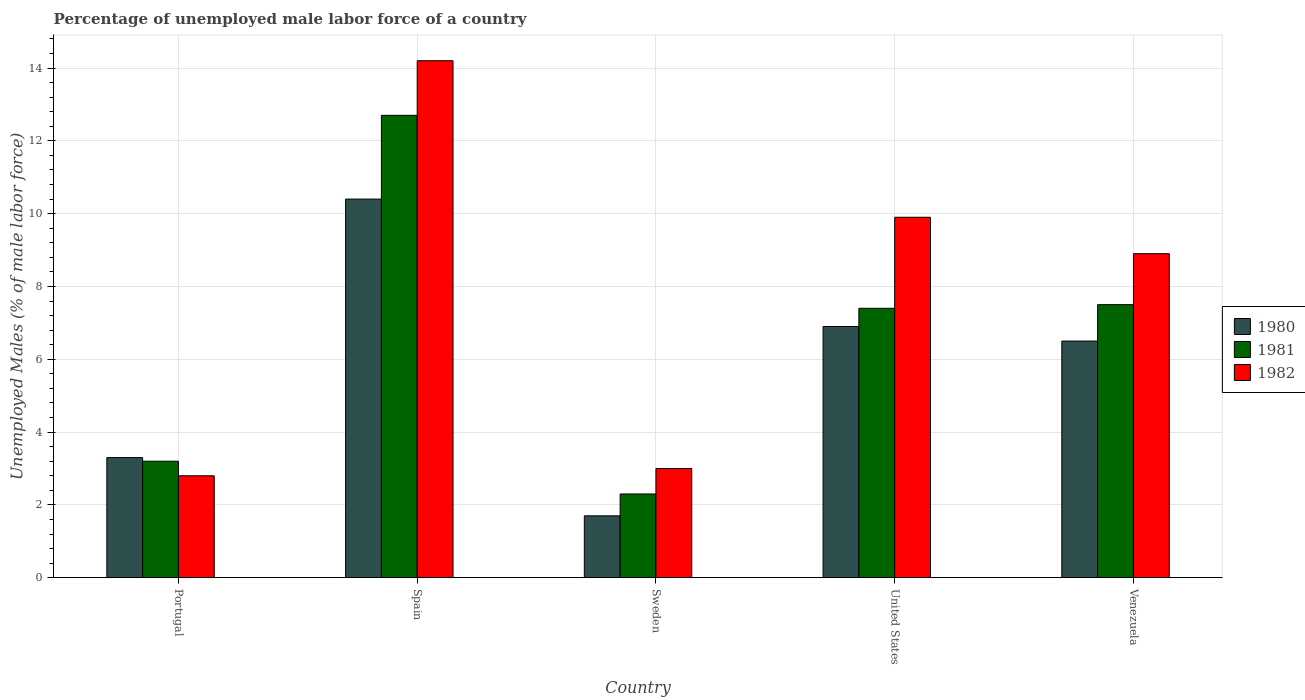Are the number of bars per tick equal to the number of legend labels?
Your answer should be very brief. Yes. What is the percentage of unemployed male labor force in 1980 in Sweden?
Your response must be concise. 1.7. Across all countries, what is the maximum percentage of unemployed male labor force in 1981?
Make the answer very short. 12.7. Across all countries, what is the minimum percentage of unemployed male labor force in 1981?
Offer a very short reply. 2.3. In which country was the percentage of unemployed male labor force in 1980 maximum?
Make the answer very short. Spain. What is the total percentage of unemployed male labor force in 1982 in the graph?
Offer a terse response. 38.8. What is the difference between the percentage of unemployed male labor force in 1980 in Portugal and that in Venezuela?
Offer a terse response. -3.2. What is the difference between the percentage of unemployed male labor force in 1981 in United States and the percentage of unemployed male labor force in 1982 in Spain?
Offer a terse response. -6.8. What is the average percentage of unemployed male labor force in 1982 per country?
Make the answer very short. 7.76. What is the difference between the percentage of unemployed male labor force of/in 1981 and percentage of unemployed male labor force of/in 1980 in United States?
Provide a succinct answer. 0.5. In how many countries, is the percentage of unemployed male labor force in 1980 greater than 3.2 %?
Provide a succinct answer. 4. What is the ratio of the percentage of unemployed male labor force in 1981 in Sweden to that in Venezuela?
Your answer should be very brief. 0.31. Is the percentage of unemployed male labor force in 1981 in Portugal less than that in Sweden?
Provide a succinct answer. No. What is the difference between the highest and the second highest percentage of unemployed male labor force in 1980?
Give a very brief answer. 3.5. What is the difference between the highest and the lowest percentage of unemployed male labor force in 1981?
Offer a very short reply. 10.4. Is the sum of the percentage of unemployed male labor force in 1981 in United States and Venezuela greater than the maximum percentage of unemployed male labor force in 1980 across all countries?
Provide a short and direct response. Yes. What does the 3rd bar from the left in Venezuela represents?
Offer a terse response. 1982. Is it the case that in every country, the sum of the percentage of unemployed male labor force in 1982 and percentage of unemployed male labor force in 1981 is greater than the percentage of unemployed male labor force in 1980?
Your response must be concise. Yes. Are all the bars in the graph horizontal?
Give a very brief answer. No. What is the difference between two consecutive major ticks on the Y-axis?
Ensure brevity in your answer.  2. Are the values on the major ticks of Y-axis written in scientific E-notation?
Ensure brevity in your answer.  No. What is the title of the graph?
Offer a very short reply. Percentage of unemployed male labor force of a country. Does "1991" appear as one of the legend labels in the graph?
Make the answer very short. No. What is the label or title of the Y-axis?
Offer a terse response. Unemployed Males (% of male labor force). What is the Unemployed Males (% of male labor force) in 1980 in Portugal?
Your response must be concise. 3.3. What is the Unemployed Males (% of male labor force) in 1981 in Portugal?
Your answer should be compact. 3.2. What is the Unemployed Males (% of male labor force) in 1982 in Portugal?
Give a very brief answer. 2.8. What is the Unemployed Males (% of male labor force) in 1980 in Spain?
Your answer should be very brief. 10.4. What is the Unemployed Males (% of male labor force) of 1981 in Spain?
Your response must be concise. 12.7. What is the Unemployed Males (% of male labor force) of 1982 in Spain?
Your answer should be very brief. 14.2. What is the Unemployed Males (% of male labor force) of 1980 in Sweden?
Provide a short and direct response. 1.7. What is the Unemployed Males (% of male labor force) in 1981 in Sweden?
Keep it short and to the point. 2.3. What is the Unemployed Males (% of male labor force) in 1980 in United States?
Provide a short and direct response. 6.9. What is the Unemployed Males (% of male labor force) in 1981 in United States?
Offer a terse response. 7.4. What is the Unemployed Males (% of male labor force) in 1982 in United States?
Make the answer very short. 9.9. What is the Unemployed Males (% of male labor force) in 1981 in Venezuela?
Your answer should be very brief. 7.5. What is the Unemployed Males (% of male labor force) in 1982 in Venezuela?
Make the answer very short. 8.9. Across all countries, what is the maximum Unemployed Males (% of male labor force) in 1980?
Your answer should be very brief. 10.4. Across all countries, what is the maximum Unemployed Males (% of male labor force) of 1981?
Give a very brief answer. 12.7. Across all countries, what is the maximum Unemployed Males (% of male labor force) of 1982?
Your answer should be compact. 14.2. Across all countries, what is the minimum Unemployed Males (% of male labor force) of 1980?
Give a very brief answer. 1.7. Across all countries, what is the minimum Unemployed Males (% of male labor force) of 1981?
Provide a short and direct response. 2.3. Across all countries, what is the minimum Unemployed Males (% of male labor force) of 1982?
Your response must be concise. 2.8. What is the total Unemployed Males (% of male labor force) of 1980 in the graph?
Offer a terse response. 28.8. What is the total Unemployed Males (% of male labor force) of 1981 in the graph?
Your response must be concise. 33.1. What is the total Unemployed Males (% of male labor force) of 1982 in the graph?
Provide a succinct answer. 38.8. What is the difference between the Unemployed Males (% of male labor force) in 1980 in Portugal and that in Spain?
Your answer should be very brief. -7.1. What is the difference between the Unemployed Males (% of male labor force) of 1981 in Portugal and that in Spain?
Provide a short and direct response. -9.5. What is the difference between the Unemployed Males (% of male labor force) of 1981 in Portugal and that in Sweden?
Offer a terse response. 0.9. What is the difference between the Unemployed Males (% of male labor force) of 1982 in Portugal and that in Sweden?
Provide a succinct answer. -0.2. What is the difference between the Unemployed Males (% of male labor force) of 1980 in Portugal and that in Venezuela?
Your answer should be very brief. -3.2. What is the difference between the Unemployed Males (% of male labor force) in 1982 in Portugal and that in Venezuela?
Provide a short and direct response. -6.1. What is the difference between the Unemployed Males (% of male labor force) in 1981 in Spain and that in Sweden?
Offer a terse response. 10.4. What is the difference between the Unemployed Males (% of male labor force) in 1982 in Spain and that in Sweden?
Ensure brevity in your answer.  11.2. What is the difference between the Unemployed Males (% of male labor force) of 1980 in Spain and that in United States?
Your response must be concise. 3.5. What is the difference between the Unemployed Males (% of male labor force) in 1981 in Spain and that in Venezuela?
Your response must be concise. 5.2. What is the difference between the Unemployed Males (% of male labor force) in 1981 in Sweden and that in Venezuela?
Give a very brief answer. -5.2. What is the difference between the Unemployed Males (% of male labor force) of 1982 in Sweden and that in Venezuela?
Ensure brevity in your answer.  -5.9. What is the difference between the Unemployed Males (% of male labor force) of 1980 in United States and that in Venezuela?
Your response must be concise. 0.4. What is the difference between the Unemployed Males (% of male labor force) of 1980 in Portugal and the Unemployed Males (% of male labor force) of 1981 in Spain?
Offer a very short reply. -9.4. What is the difference between the Unemployed Males (% of male labor force) of 1981 in Portugal and the Unemployed Males (% of male labor force) of 1982 in Spain?
Offer a terse response. -11. What is the difference between the Unemployed Males (% of male labor force) of 1980 in Portugal and the Unemployed Males (% of male labor force) of 1982 in Sweden?
Offer a terse response. 0.3. What is the difference between the Unemployed Males (% of male labor force) in 1980 in Portugal and the Unemployed Males (% of male labor force) in 1981 in United States?
Keep it short and to the point. -4.1. What is the difference between the Unemployed Males (% of male labor force) in 1980 in Portugal and the Unemployed Males (% of male labor force) in 1982 in United States?
Ensure brevity in your answer.  -6.6. What is the difference between the Unemployed Males (% of male labor force) of 1981 in Portugal and the Unemployed Males (% of male labor force) of 1982 in United States?
Ensure brevity in your answer.  -6.7. What is the difference between the Unemployed Males (% of male labor force) of 1980 in Portugal and the Unemployed Males (% of male labor force) of 1981 in Venezuela?
Your response must be concise. -4.2. What is the difference between the Unemployed Males (% of male labor force) in 1981 in Portugal and the Unemployed Males (% of male labor force) in 1982 in Venezuela?
Your response must be concise. -5.7. What is the difference between the Unemployed Males (% of male labor force) of 1980 in Spain and the Unemployed Males (% of male labor force) of 1981 in Sweden?
Provide a succinct answer. 8.1. What is the difference between the Unemployed Males (% of male labor force) in 1980 in Spain and the Unemployed Males (% of male labor force) in 1982 in United States?
Provide a short and direct response. 0.5. What is the difference between the Unemployed Males (% of male labor force) in 1980 in Spain and the Unemployed Males (% of male labor force) in 1982 in Venezuela?
Provide a short and direct response. 1.5. What is the difference between the Unemployed Males (% of male labor force) of 1980 in Sweden and the Unemployed Males (% of male labor force) of 1981 in Venezuela?
Provide a succinct answer. -5.8. What is the difference between the Unemployed Males (% of male labor force) in 1981 in Sweden and the Unemployed Males (% of male labor force) in 1982 in Venezuela?
Make the answer very short. -6.6. What is the difference between the Unemployed Males (% of male labor force) of 1980 in United States and the Unemployed Males (% of male labor force) of 1982 in Venezuela?
Make the answer very short. -2. What is the average Unemployed Males (% of male labor force) in 1980 per country?
Make the answer very short. 5.76. What is the average Unemployed Males (% of male labor force) of 1981 per country?
Ensure brevity in your answer.  6.62. What is the average Unemployed Males (% of male labor force) in 1982 per country?
Provide a short and direct response. 7.76. What is the difference between the Unemployed Males (% of male labor force) in 1980 and Unemployed Males (% of male labor force) in 1982 in Spain?
Keep it short and to the point. -3.8. What is the difference between the Unemployed Males (% of male labor force) of 1981 and Unemployed Males (% of male labor force) of 1982 in Spain?
Your answer should be compact. -1.5. What is the difference between the Unemployed Males (% of male labor force) of 1980 and Unemployed Males (% of male labor force) of 1982 in Sweden?
Provide a short and direct response. -1.3. What is the difference between the Unemployed Males (% of male labor force) of 1981 and Unemployed Males (% of male labor force) of 1982 in Sweden?
Provide a short and direct response. -0.7. What is the difference between the Unemployed Males (% of male labor force) in 1980 and Unemployed Males (% of male labor force) in 1981 in United States?
Provide a short and direct response. -0.5. What is the difference between the Unemployed Males (% of male labor force) in 1980 and Unemployed Males (% of male labor force) in 1982 in United States?
Give a very brief answer. -3. What is the difference between the Unemployed Males (% of male labor force) in 1981 and Unemployed Males (% of male labor force) in 1982 in United States?
Offer a terse response. -2.5. What is the difference between the Unemployed Males (% of male labor force) in 1980 and Unemployed Males (% of male labor force) in 1981 in Venezuela?
Ensure brevity in your answer.  -1. What is the difference between the Unemployed Males (% of male labor force) of 1980 and Unemployed Males (% of male labor force) of 1982 in Venezuela?
Offer a terse response. -2.4. What is the ratio of the Unemployed Males (% of male labor force) of 1980 in Portugal to that in Spain?
Your answer should be compact. 0.32. What is the ratio of the Unemployed Males (% of male labor force) of 1981 in Portugal to that in Spain?
Provide a succinct answer. 0.25. What is the ratio of the Unemployed Males (% of male labor force) of 1982 in Portugal to that in Spain?
Make the answer very short. 0.2. What is the ratio of the Unemployed Males (% of male labor force) in 1980 in Portugal to that in Sweden?
Give a very brief answer. 1.94. What is the ratio of the Unemployed Males (% of male labor force) in 1981 in Portugal to that in Sweden?
Your answer should be very brief. 1.39. What is the ratio of the Unemployed Males (% of male labor force) of 1980 in Portugal to that in United States?
Keep it short and to the point. 0.48. What is the ratio of the Unemployed Males (% of male labor force) of 1981 in Portugal to that in United States?
Provide a short and direct response. 0.43. What is the ratio of the Unemployed Males (% of male labor force) in 1982 in Portugal to that in United States?
Keep it short and to the point. 0.28. What is the ratio of the Unemployed Males (% of male labor force) in 1980 in Portugal to that in Venezuela?
Provide a succinct answer. 0.51. What is the ratio of the Unemployed Males (% of male labor force) in 1981 in Portugal to that in Venezuela?
Ensure brevity in your answer.  0.43. What is the ratio of the Unemployed Males (% of male labor force) in 1982 in Portugal to that in Venezuela?
Your answer should be very brief. 0.31. What is the ratio of the Unemployed Males (% of male labor force) of 1980 in Spain to that in Sweden?
Your answer should be very brief. 6.12. What is the ratio of the Unemployed Males (% of male labor force) in 1981 in Spain to that in Sweden?
Make the answer very short. 5.52. What is the ratio of the Unemployed Males (% of male labor force) of 1982 in Spain to that in Sweden?
Your answer should be compact. 4.73. What is the ratio of the Unemployed Males (% of male labor force) of 1980 in Spain to that in United States?
Keep it short and to the point. 1.51. What is the ratio of the Unemployed Males (% of male labor force) of 1981 in Spain to that in United States?
Your response must be concise. 1.72. What is the ratio of the Unemployed Males (% of male labor force) of 1982 in Spain to that in United States?
Your answer should be very brief. 1.43. What is the ratio of the Unemployed Males (% of male labor force) of 1980 in Spain to that in Venezuela?
Provide a short and direct response. 1.6. What is the ratio of the Unemployed Males (% of male labor force) in 1981 in Spain to that in Venezuela?
Keep it short and to the point. 1.69. What is the ratio of the Unemployed Males (% of male labor force) in 1982 in Spain to that in Venezuela?
Keep it short and to the point. 1.6. What is the ratio of the Unemployed Males (% of male labor force) in 1980 in Sweden to that in United States?
Give a very brief answer. 0.25. What is the ratio of the Unemployed Males (% of male labor force) in 1981 in Sweden to that in United States?
Provide a succinct answer. 0.31. What is the ratio of the Unemployed Males (% of male labor force) of 1982 in Sweden to that in United States?
Your answer should be very brief. 0.3. What is the ratio of the Unemployed Males (% of male labor force) in 1980 in Sweden to that in Venezuela?
Give a very brief answer. 0.26. What is the ratio of the Unemployed Males (% of male labor force) of 1981 in Sweden to that in Venezuela?
Provide a short and direct response. 0.31. What is the ratio of the Unemployed Males (% of male labor force) of 1982 in Sweden to that in Venezuela?
Your answer should be compact. 0.34. What is the ratio of the Unemployed Males (% of male labor force) in 1980 in United States to that in Venezuela?
Provide a short and direct response. 1.06. What is the ratio of the Unemployed Males (% of male labor force) in 1981 in United States to that in Venezuela?
Give a very brief answer. 0.99. What is the ratio of the Unemployed Males (% of male labor force) of 1982 in United States to that in Venezuela?
Make the answer very short. 1.11. What is the difference between the highest and the second highest Unemployed Males (% of male labor force) in 1982?
Provide a succinct answer. 4.3. What is the difference between the highest and the lowest Unemployed Males (% of male labor force) of 1981?
Provide a succinct answer. 10.4. 